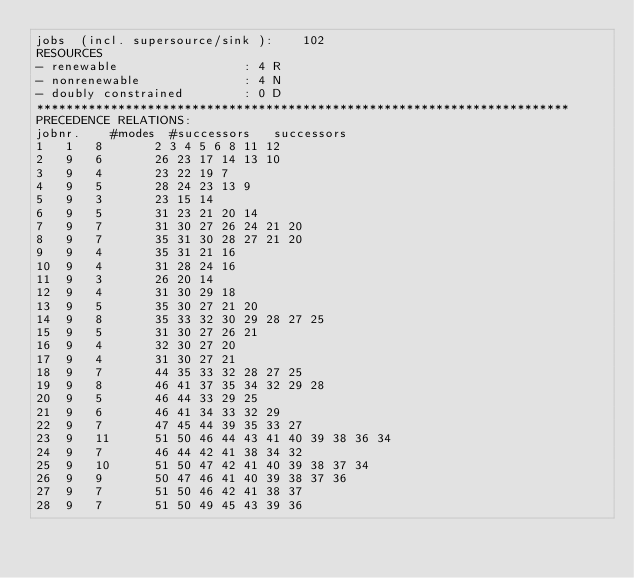<code> <loc_0><loc_0><loc_500><loc_500><_ObjectiveC_>jobs  (incl. supersource/sink ):	102
RESOURCES
- renewable                 : 4 R
- nonrenewable              : 4 N
- doubly constrained        : 0 D
************************************************************************
PRECEDENCE RELATIONS:
jobnr.    #modes  #successors   successors
1	1	8		2 3 4 5 6 8 11 12 
2	9	6		26 23 17 14 13 10 
3	9	4		23 22 19 7 
4	9	5		28 24 23 13 9 
5	9	3		23 15 14 
6	9	5		31 23 21 20 14 
7	9	7		31 30 27 26 24 21 20 
8	9	7		35 31 30 28 27 21 20 
9	9	4		35 31 21 16 
10	9	4		31 28 24 16 
11	9	3		26 20 14 
12	9	4		31 30 29 18 
13	9	5		35 30 27 21 20 
14	9	8		35 33 32 30 29 28 27 25 
15	9	5		31 30 27 26 21 
16	9	4		32 30 27 20 
17	9	4		31 30 27 21 
18	9	7		44 35 33 32 28 27 25 
19	9	8		46 41 37 35 34 32 29 28 
20	9	5		46 44 33 29 25 
21	9	6		46 41 34 33 32 29 
22	9	7		47 45 44 39 35 33 27 
23	9	11		51 50 46 44 43 41 40 39 38 36 34 
24	9	7		46 44 42 41 38 34 32 
25	9	10		51 50 47 42 41 40 39 38 37 34 
26	9	9		50 47 46 41 40 39 38 37 36 
27	9	7		51 50 46 42 41 38 37 
28	9	7		51 50 49 45 43 39 36 </code> 